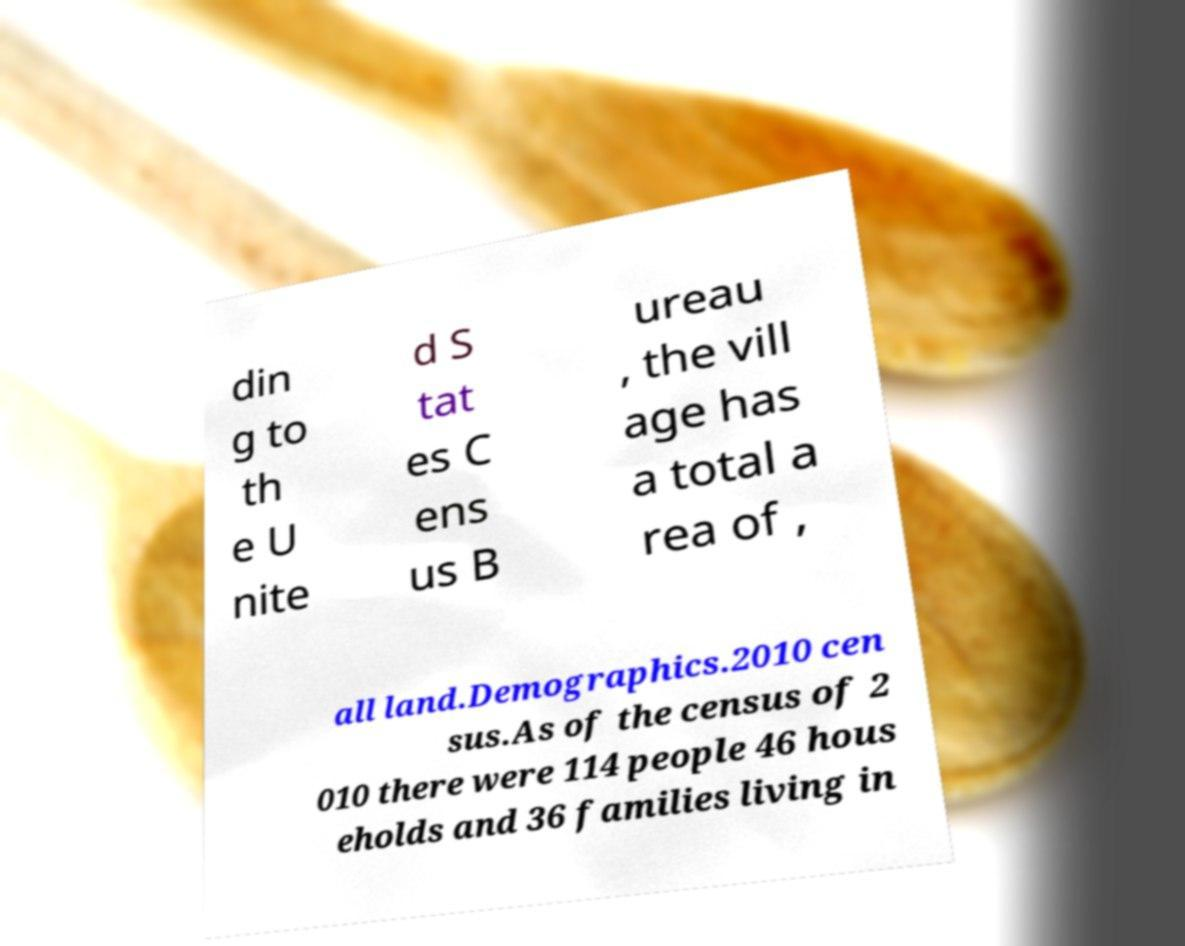Could you extract and type out the text from this image? din g to th e U nite d S tat es C ens us B ureau , the vill age has a total a rea of , all land.Demographics.2010 cen sus.As of the census of 2 010 there were 114 people 46 hous eholds and 36 families living in 